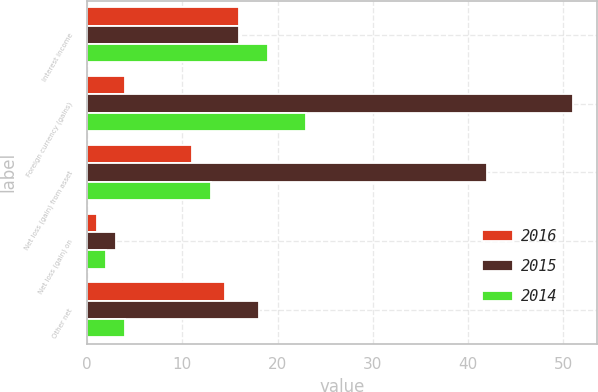Convert chart to OTSL. <chart><loc_0><loc_0><loc_500><loc_500><stacked_bar_chart><ecel><fcel>Interest income<fcel>Foreign currency (gains)<fcel>Net loss (gain) from asset<fcel>Net loss (gain) on<fcel>Other net<nl><fcel>2016<fcel>16<fcel>4<fcel>11<fcel>1<fcel>14.5<nl><fcel>2015<fcel>16<fcel>51<fcel>42<fcel>3<fcel>18<nl><fcel>2014<fcel>19<fcel>23<fcel>13<fcel>2<fcel>4<nl></chart> 